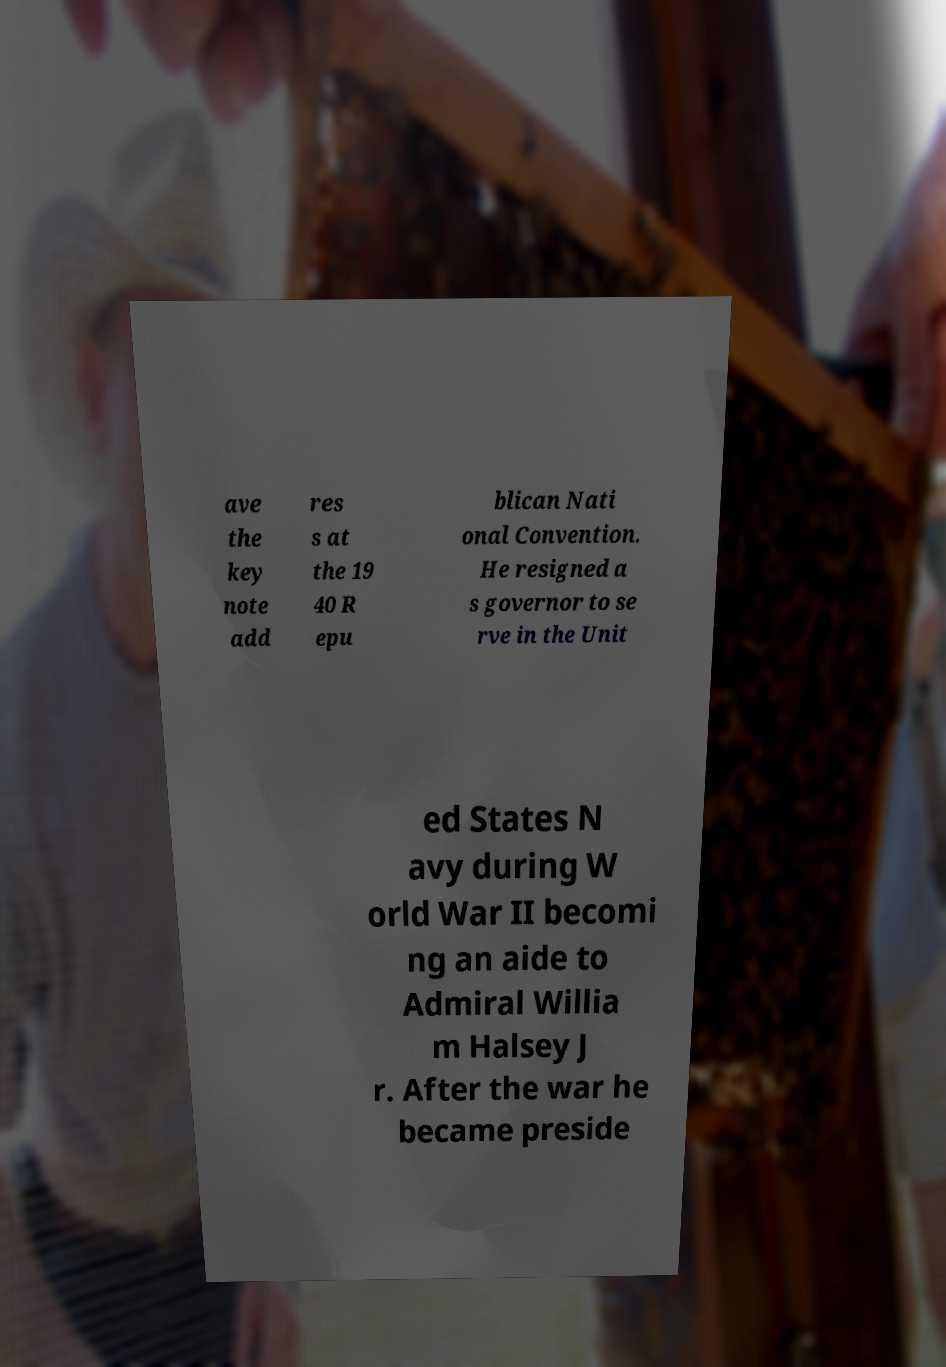For documentation purposes, I need the text within this image transcribed. Could you provide that? ave the key note add res s at the 19 40 R epu blican Nati onal Convention. He resigned a s governor to se rve in the Unit ed States N avy during W orld War II becomi ng an aide to Admiral Willia m Halsey J r. After the war he became preside 